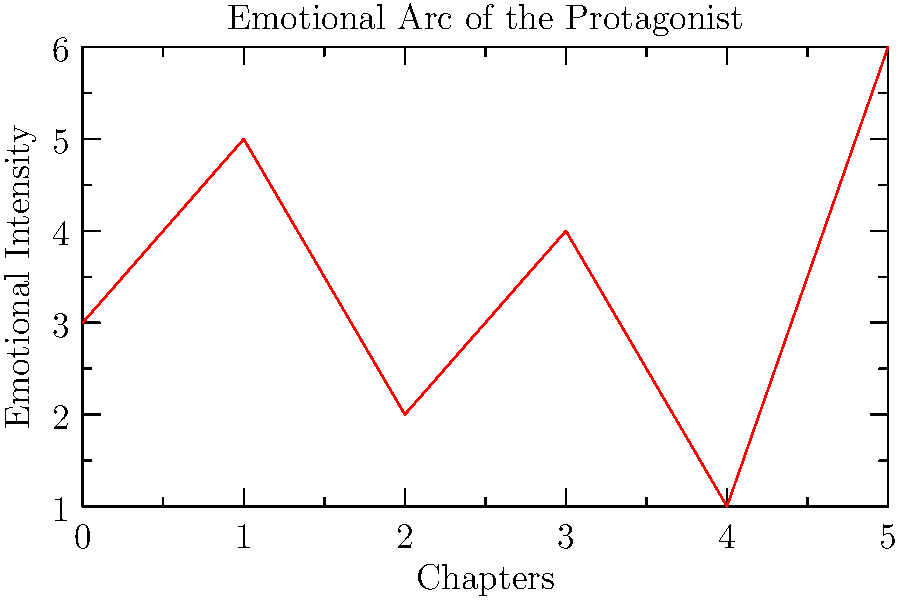Analyze the emotional arc of the protagonist as shown in the line graph. Which chapter represents the protagonist's lowest emotional point, and what literary technique might the author be employing at this point in the story? To answer this question, we need to follow these steps:

1. Examine the graph:
   The x-axis represents chapters, and the y-axis represents emotional intensity.

2. Identify the lowest point:
   The lowest point on the graph occurs at x = 4, y = 1.

3. Interpret the lowest point:
   This corresponds to Chapter 4, which represents the protagonist's lowest emotional state.

4. Consider literary techniques:
   The dramatic drop to the lowest point in Chapter 4 suggests the author may be using the literary technique of "the dark night of the soul" or "the crisis/climax" moment.

5. Understand the technique:
   This is typically a moment of intense conflict or despair for the protagonist, often occurring near the end of the story's middle section. It sets up the final resolution or transformation.

6. Analyze the arc:
   The subsequent rise in Chapter 5 indicates a potential resolution or character growth following this low point, which is characteristic of this literary technique.
Answer: Chapter 4; dark night of the soul/crisis moment 